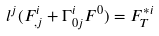<formula> <loc_0><loc_0><loc_500><loc_500>l ^ { j } ( F _ { , j } ^ { i } + \Gamma _ { 0 j } ^ { i } F ^ { 0 } ) = F _ { T } ^ { * i }</formula> 